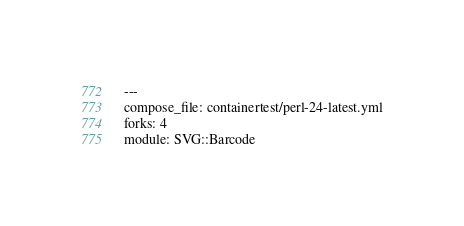<code> <loc_0><loc_0><loc_500><loc_500><_YAML_>---
compose_file: containertest/perl-24-latest.yml
forks: 4
module: SVG::Barcode
</code> 